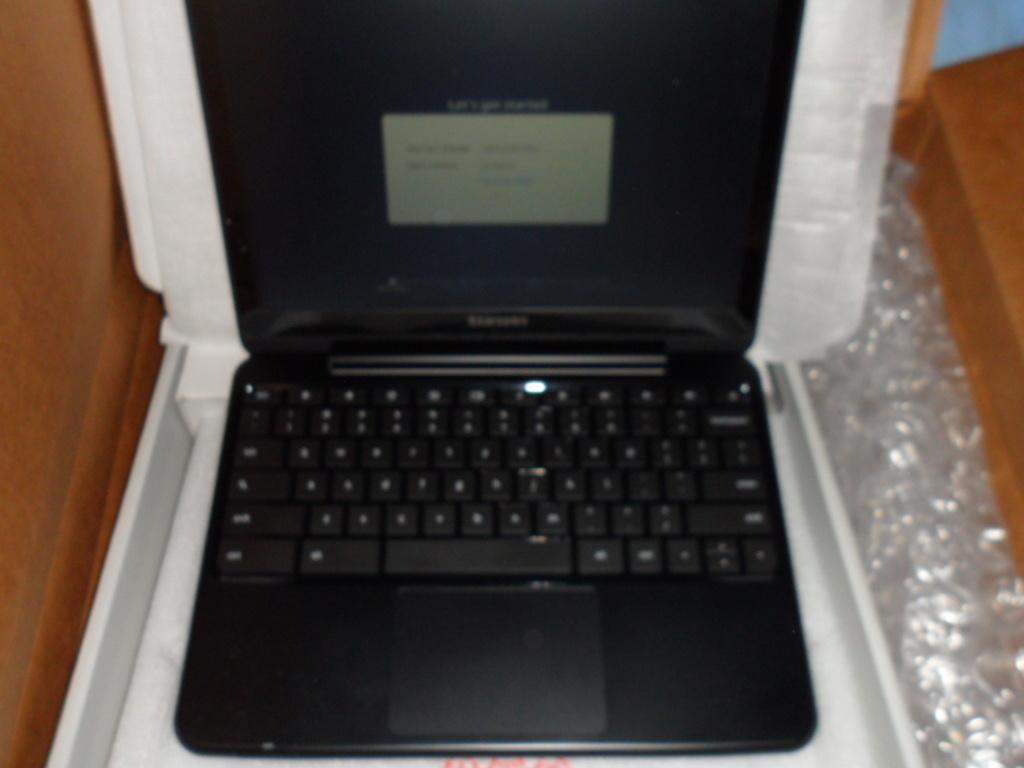What electronic device is visible in the image? There is a laptop in the image. What is covering the laptop? There is a cover in the image. What object can be seen on the right side of the image? The facts do not specify the object on the right side of the image. What type of pen is being used to write on the oven in the image? There is no pen or oven present in the image. 